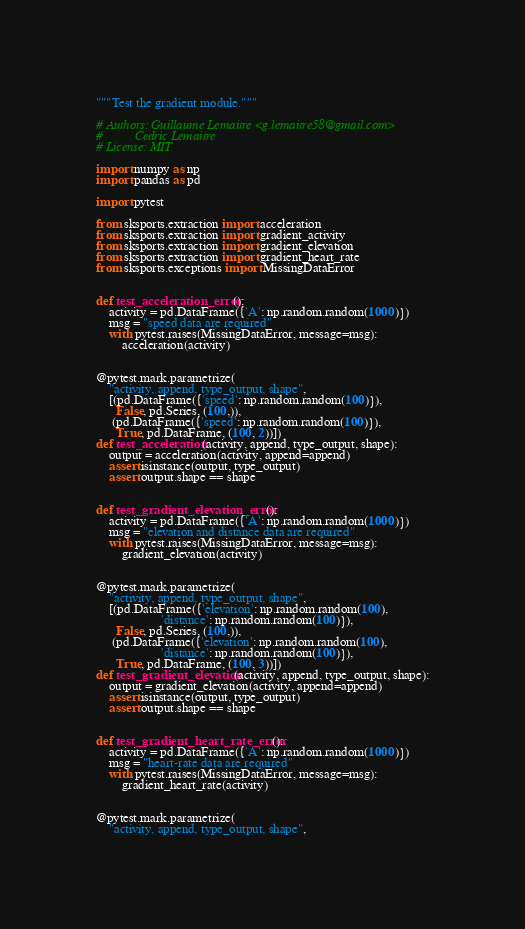Convert code to text. <code><loc_0><loc_0><loc_500><loc_500><_Python_>"""Test the gradient module."""

# Authors: Guillaume Lemaitre <g.lemaitre58@gmail.com>
#          Cedric Lemaitre
# License: MIT

import numpy as np
import pandas as pd

import pytest

from sksports.extraction import acceleration
from sksports.extraction import gradient_activity
from sksports.extraction import gradient_elevation
from sksports.extraction import gradient_heart_rate
from sksports.exceptions import MissingDataError


def test_acceleration_error():
    activity = pd.DataFrame({'A': np.random.random(1000)})
    msg = "speed data are required"
    with pytest.raises(MissingDataError, message=msg):
        acceleration(activity)


@pytest.mark.parametrize(
    "activity, append, type_output, shape",
    [(pd.DataFrame({'speed': np.random.random(100)}),
      False, pd.Series, (100,)),
     (pd.DataFrame({'speed': np.random.random(100)}),
      True, pd.DataFrame, (100, 2))])
def test_acceleration(activity, append, type_output, shape):
    output = acceleration(activity, append=append)
    assert isinstance(output, type_output)
    assert output.shape == shape


def test_gradient_elevation_error():
    activity = pd.DataFrame({'A': np.random.random(1000)})
    msg = "elevation and distance data are required"
    with pytest.raises(MissingDataError, message=msg):
        gradient_elevation(activity)


@pytest.mark.parametrize(
    "activity, append, type_output, shape",
    [(pd.DataFrame({'elevation': np.random.random(100),
                    'distance': np.random.random(100)}),
      False, pd.Series, (100,)),
     (pd.DataFrame({'elevation': np.random.random(100),
                    'distance': np.random.random(100)}),
      True, pd.DataFrame, (100, 3))])
def test_gradient_elevation(activity, append, type_output, shape):
    output = gradient_elevation(activity, append=append)
    assert isinstance(output, type_output)
    assert output.shape == shape


def test_gradient_heart_rate_error():
    activity = pd.DataFrame({'A': np.random.random(1000)})
    msg = "heart-rate data are required"
    with pytest.raises(MissingDataError, message=msg):
        gradient_heart_rate(activity)


@pytest.mark.parametrize(
    "activity, append, type_output, shape",</code> 